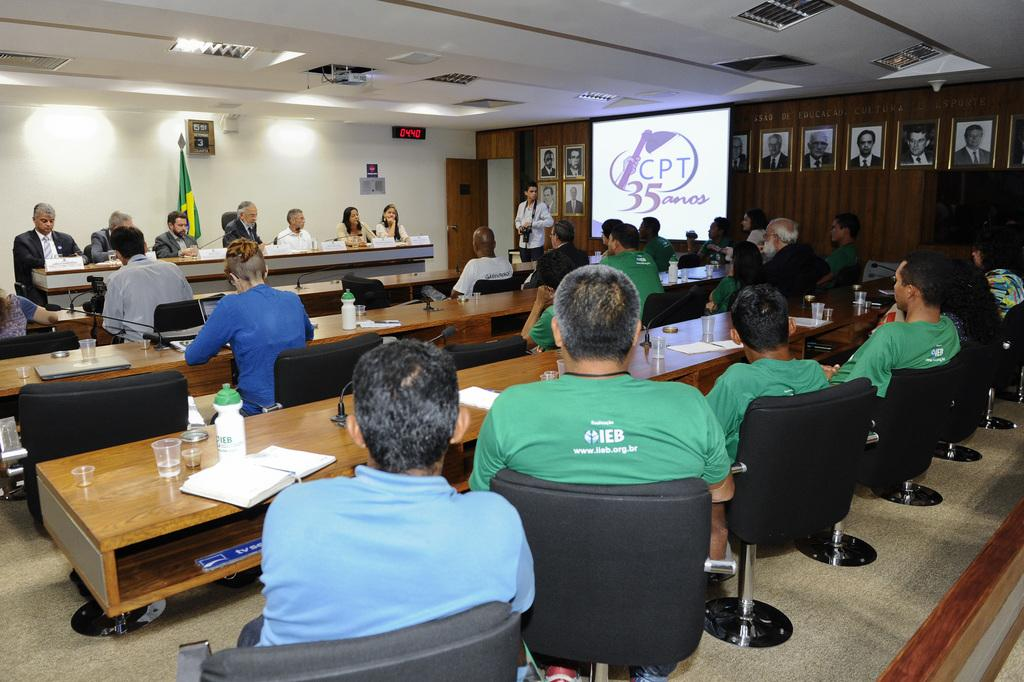What is the main activity of the people in the image? The main activity of the people in the image is sitting and talking. How are the people arranged in the image? There is a group of people sitting in chairs, and a person sitting at a table. What is the relationship between the people at the table and the group in chairs? The people at the table are talking to the group in chairs. What type of powder is being used by the governor in the image? There is no governor or powder present in the image. 